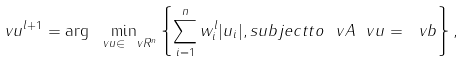Convert formula to latex. <formula><loc_0><loc_0><loc_500><loc_500>\ v u ^ { l + 1 } = \arg \min _ { \ v u \in \ v R ^ { n } } \left \{ \sum _ { i = 1 } ^ { n } w ^ { l } _ { i } | u _ { i } | , s u b j e c t t o \ v A \ v u = \ v b \right \} ,</formula> 